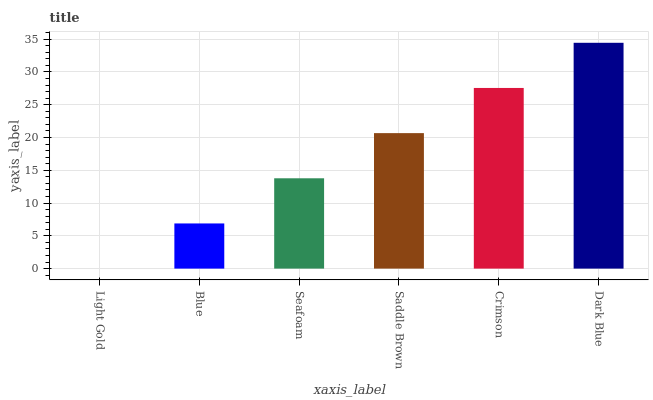Is Blue the minimum?
Answer yes or no. No. Is Blue the maximum?
Answer yes or no. No. Is Blue greater than Light Gold?
Answer yes or no. Yes. Is Light Gold less than Blue?
Answer yes or no. Yes. Is Light Gold greater than Blue?
Answer yes or no. No. Is Blue less than Light Gold?
Answer yes or no. No. Is Saddle Brown the high median?
Answer yes or no. Yes. Is Seafoam the low median?
Answer yes or no. Yes. Is Light Gold the high median?
Answer yes or no. No. Is Saddle Brown the low median?
Answer yes or no. No. 